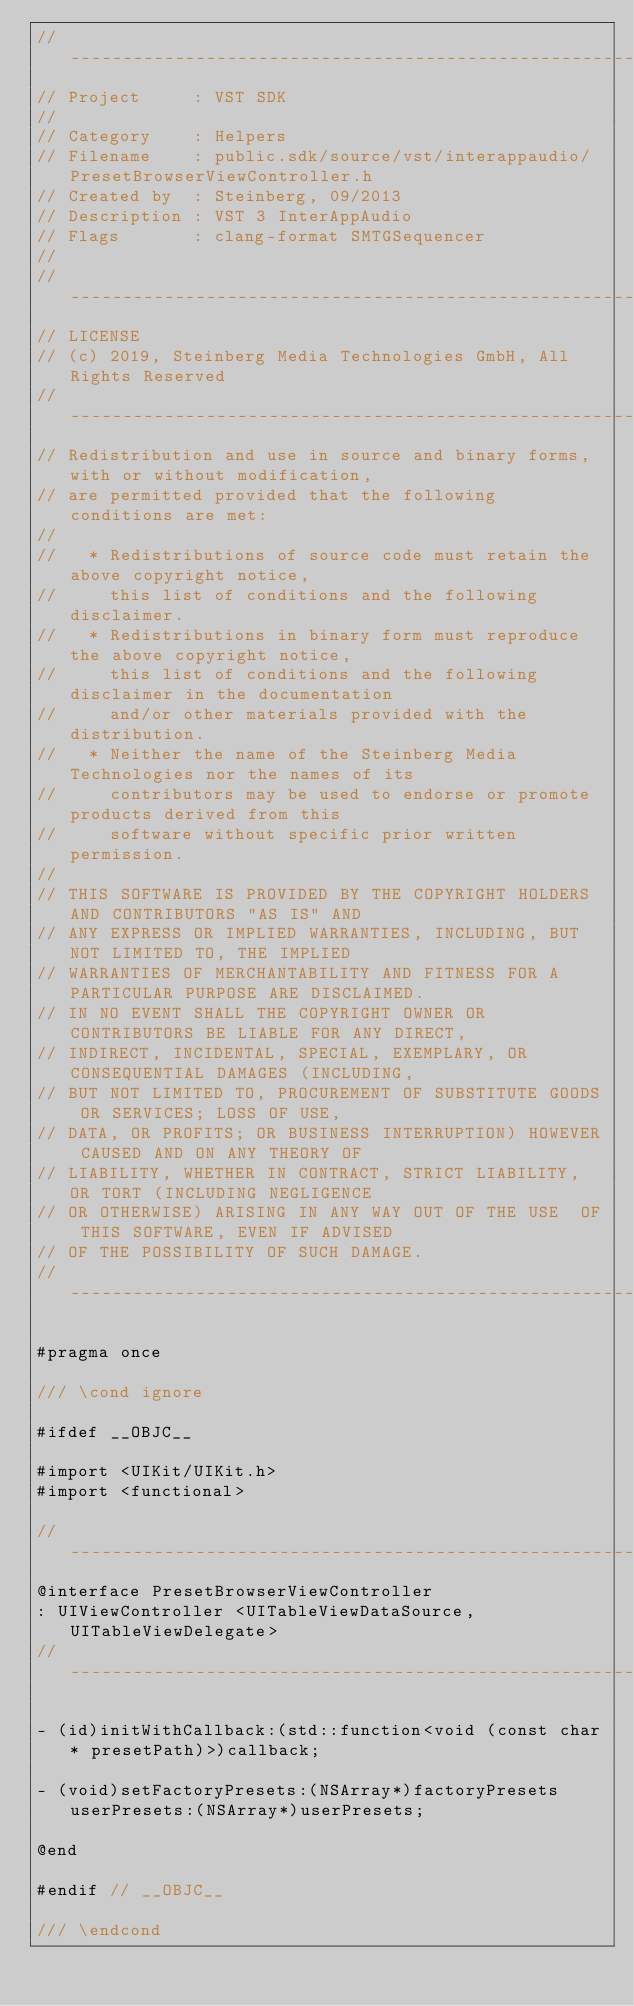Convert code to text. <code><loc_0><loc_0><loc_500><loc_500><_C_>//-----------------------------------------------------------------------------
// Project     : VST SDK
//
// Category    : Helpers
// Filename    : public.sdk/source/vst/interappaudio/PresetBrowserViewController.h
// Created by  : Steinberg, 09/2013
// Description : VST 3 InterAppAudio
// Flags       : clang-format SMTGSequencer
//
//-----------------------------------------------------------------------------
// LICENSE
// (c) 2019, Steinberg Media Technologies GmbH, All Rights Reserved
//-----------------------------------------------------------------------------
// Redistribution and use in source and binary forms, with or without modification,
// are permitted provided that the following conditions are met:
//
//   * Redistributions of source code must retain the above copyright notice,
//     this list of conditions and the following disclaimer.
//   * Redistributions in binary form must reproduce the above copyright notice,
//     this list of conditions and the following disclaimer in the documentation
//     and/or other materials provided with the distribution.
//   * Neither the name of the Steinberg Media Technologies nor the names of its
//     contributors may be used to endorse or promote products derived from this
//     software without specific prior written permission.
//
// THIS SOFTWARE IS PROVIDED BY THE COPYRIGHT HOLDERS AND CONTRIBUTORS "AS IS" AND
// ANY EXPRESS OR IMPLIED WARRANTIES, INCLUDING, BUT NOT LIMITED TO, THE IMPLIED
// WARRANTIES OF MERCHANTABILITY AND FITNESS FOR A PARTICULAR PURPOSE ARE DISCLAIMED.
// IN NO EVENT SHALL THE COPYRIGHT OWNER OR CONTRIBUTORS BE LIABLE FOR ANY DIRECT,
// INDIRECT, INCIDENTAL, SPECIAL, EXEMPLARY, OR CONSEQUENTIAL DAMAGES (INCLUDING,
// BUT NOT LIMITED TO, PROCUREMENT OF SUBSTITUTE GOODS OR SERVICES; LOSS OF USE,
// DATA, OR PROFITS; OR BUSINESS INTERRUPTION) HOWEVER CAUSED AND ON ANY THEORY OF
// LIABILITY, WHETHER IN CONTRACT, STRICT LIABILITY, OR TORT (INCLUDING NEGLIGENCE
// OR OTHERWISE) ARISING IN ANY WAY OUT OF THE USE  OF THIS SOFTWARE, EVEN IF ADVISED
// OF THE POSSIBILITY OF SUCH DAMAGE.
//-----------------------------------------------------------------------------

#pragma once

/// \cond ignore

#ifdef __OBJC__

#import <UIKit/UIKit.h>
#import <functional>

//-----------------------------------------------------------------------------
@interface PresetBrowserViewController
: UIViewController <UITableViewDataSource, UITableViewDelegate>
//-----------------------------------------------------------------------------

- (id)initWithCallback:(std::function<void (const char* presetPath)>)callback;

- (void)setFactoryPresets:(NSArray*)factoryPresets userPresets:(NSArray*)userPresets;

@end

#endif // __OBJC__

/// \endcond
</code> 